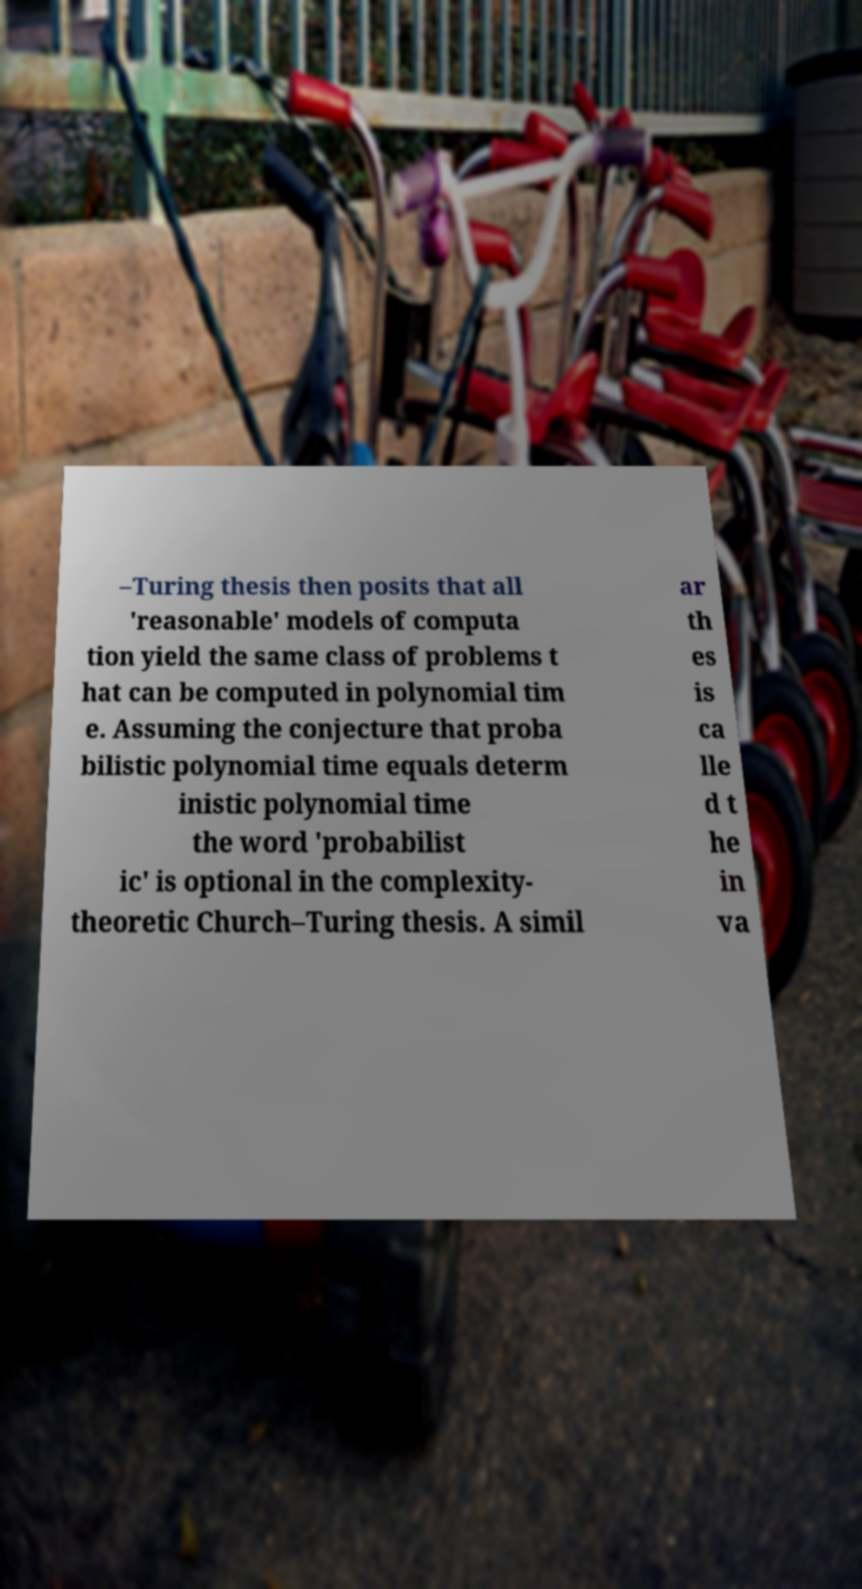Can you read and provide the text displayed in the image?This photo seems to have some interesting text. Can you extract and type it out for me? –Turing thesis then posits that all 'reasonable' models of computa tion yield the same class of problems t hat can be computed in polynomial tim e. Assuming the conjecture that proba bilistic polynomial time equals determ inistic polynomial time the word 'probabilist ic' is optional in the complexity- theoretic Church–Turing thesis. A simil ar th es is ca lle d t he in va 